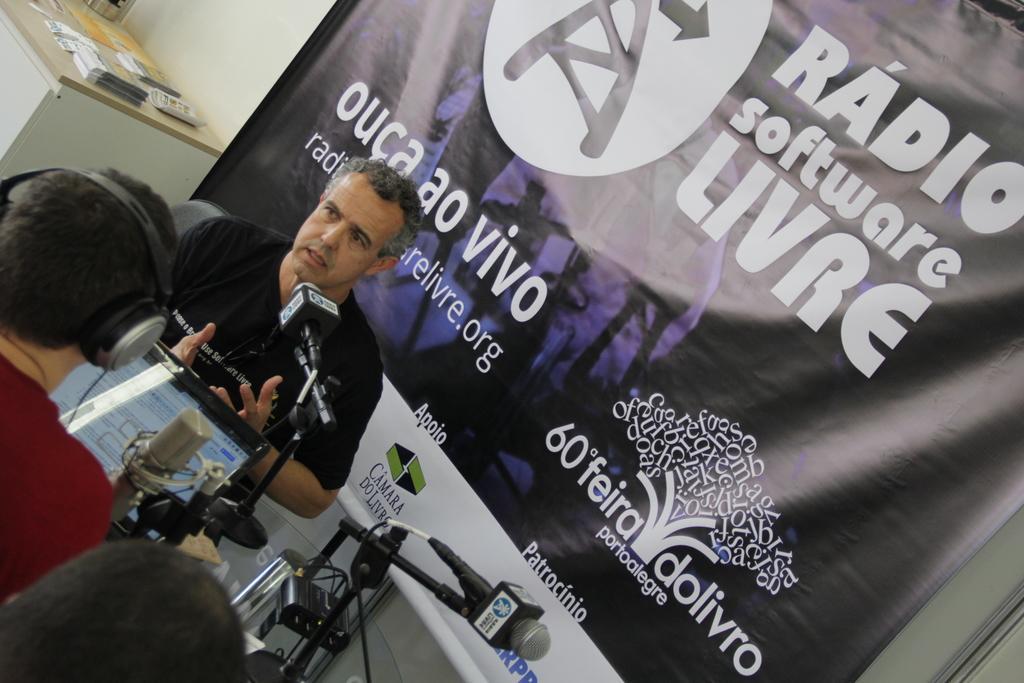Can you describe this image briefly? In the background we can see the wall, banner. On a table we can see objects. In this picture we can see a man, looks like he is talking. On the left side of the picture we can see a person wearing headsets. We can see microphones, stands, screen and objects. 